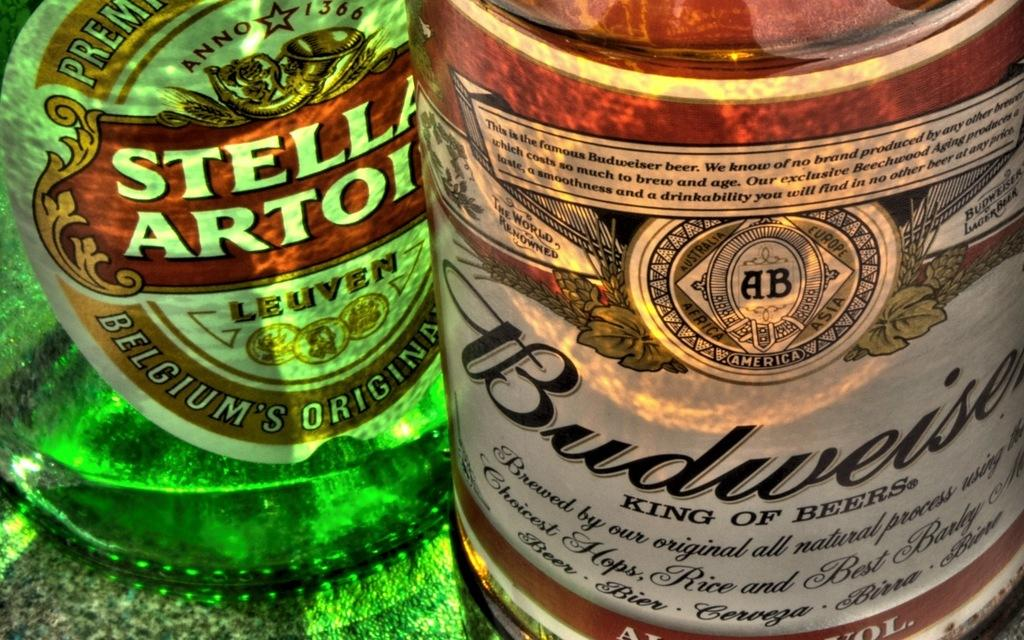Provide a one-sentence caption for the provided image. A bottle from Belgium sits next to a Budweiser bottle. 